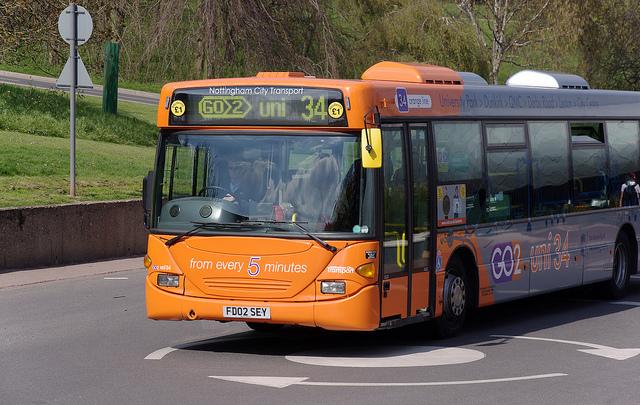Is this a solar powered bus?
Keep it brief. No. Where is the bus?
Answer briefly. Street. Is the bus moving or stopped?
Keep it brief. Moving. What color is the bus?
Give a very brief answer. Orange. What is the bus number?
Write a very short answer. 34. What does the sign  say?
Write a very short answer. Uni. Where are these buses most often found?
Give a very brief answer. City. 